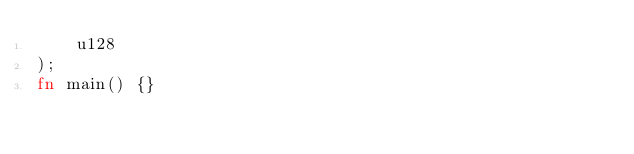Convert code to text. <code><loc_0><loc_0><loc_500><loc_500><_Rust_>    u128
);
fn main() {}
</code> 